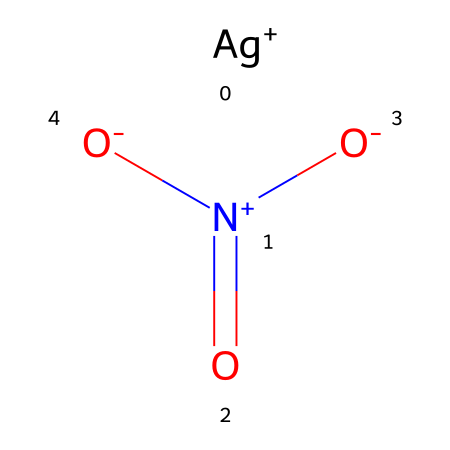how many atoms are in silver nitrate? The chemical structure indicates one silver (Ag) atom, one nitrogen (N) atom, and three oxygen (O) atoms, totaling five atoms.
Answer: five what is the oxidation state of silver in this compound? The notation [Ag+] indicates that silver has a +1 oxidation state in this compound.
Answer: +1 how many bonds are present in silver nitrate? One silver atom is bonded to one nitrogen atom, which is bonded to three oxygen atoms. In total, there are four bonds: one Ag-N bond and three N-O bonds.
Answer: four what is the primary role of silver nitrate in film development? Silver nitrate is used to produce light-sensitive silver halides for film development processes.
Answer: light-sensitive what type of chemical is silver nitrate? Silver nitrate is classified as a metal nitrate compound due to the presence of the metal silver and the nitrate ion.
Answer: metal nitrate why does silver nitrate have a prominent role in photography? Silver ions in silver nitrate can form light-sensitive compounds, particularly silver halides, which are critical for capturing images on photographic film.
Answer: light-sensitive compounds what structural feature indicates the presence of a nitrate ion in silver nitrate? The presence of the nitrogen atom bonded to three oxygen atoms (one of which has a double bond with nitrogen) indicates the nitrate ion structure.
Answer: nitrogen with three oxygens 